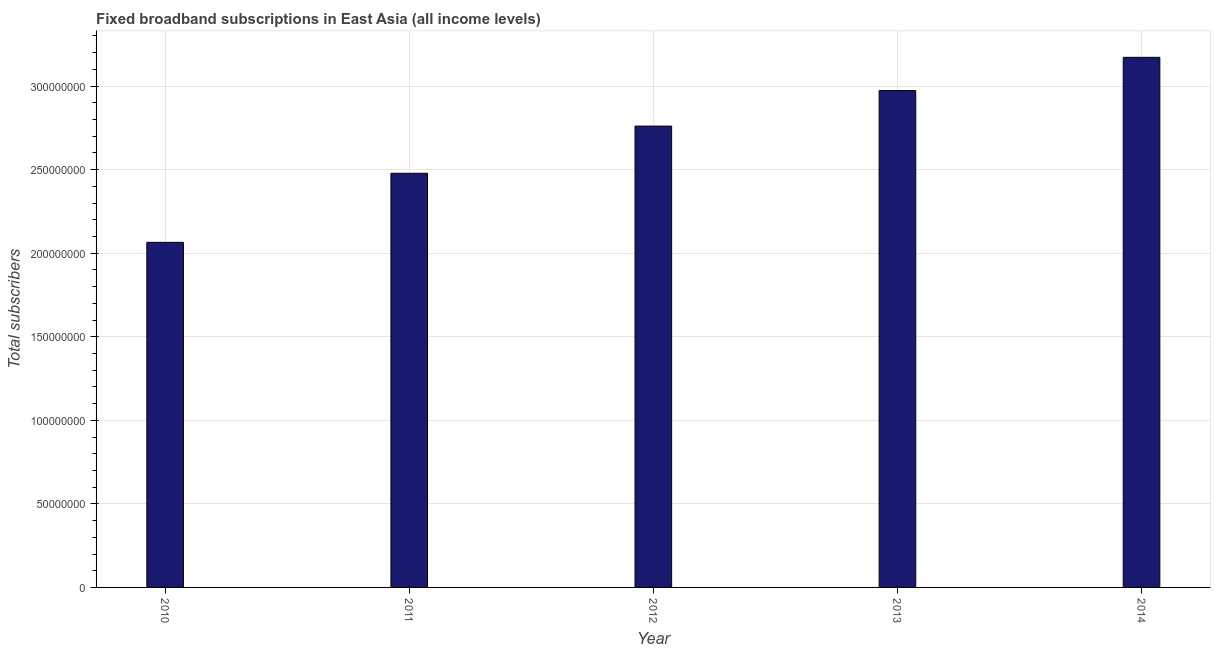What is the title of the graph?
Make the answer very short. Fixed broadband subscriptions in East Asia (all income levels). What is the label or title of the Y-axis?
Your response must be concise. Total subscribers. What is the total number of fixed broadband subscriptions in 2012?
Your response must be concise. 2.76e+08. Across all years, what is the maximum total number of fixed broadband subscriptions?
Make the answer very short. 3.17e+08. Across all years, what is the minimum total number of fixed broadband subscriptions?
Keep it short and to the point. 2.06e+08. In which year was the total number of fixed broadband subscriptions minimum?
Offer a very short reply. 2010. What is the sum of the total number of fixed broadband subscriptions?
Your answer should be compact. 1.34e+09. What is the difference between the total number of fixed broadband subscriptions in 2012 and 2013?
Your answer should be compact. -2.12e+07. What is the average total number of fixed broadband subscriptions per year?
Make the answer very short. 2.69e+08. What is the median total number of fixed broadband subscriptions?
Keep it short and to the point. 2.76e+08. In how many years, is the total number of fixed broadband subscriptions greater than 70000000 ?
Provide a succinct answer. 5. What is the ratio of the total number of fixed broadband subscriptions in 2011 to that in 2013?
Your answer should be compact. 0.83. Is the difference between the total number of fixed broadband subscriptions in 2010 and 2012 greater than the difference between any two years?
Your answer should be very brief. No. What is the difference between the highest and the second highest total number of fixed broadband subscriptions?
Offer a terse response. 1.99e+07. Is the sum of the total number of fixed broadband subscriptions in 2011 and 2012 greater than the maximum total number of fixed broadband subscriptions across all years?
Offer a very short reply. Yes. What is the difference between the highest and the lowest total number of fixed broadband subscriptions?
Offer a very short reply. 1.11e+08. In how many years, is the total number of fixed broadband subscriptions greater than the average total number of fixed broadband subscriptions taken over all years?
Your answer should be very brief. 3. Are all the bars in the graph horizontal?
Your answer should be very brief. No. What is the difference between two consecutive major ticks on the Y-axis?
Offer a very short reply. 5.00e+07. What is the Total subscribers in 2010?
Provide a succinct answer. 2.06e+08. What is the Total subscribers in 2011?
Provide a short and direct response. 2.48e+08. What is the Total subscribers in 2012?
Provide a succinct answer. 2.76e+08. What is the Total subscribers of 2013?
Make the answer very short. 2.97e+08. What is the Total subscribers in 2014?
Offer a very short reply. 3.17e+08. What is the difference between the Total subscribers in 2010 and 2011?
Ensure brevity in your answer.  -4.13e+07. What is the difference between the Total subscribers in 2010 and 2012?
Keep it short and to the point. -6.96e+07. What is the difference between the Total subscribers in 2010 and 2013?
Provide a succinct answer. -9.08e+07. What is the difference between the Total subscribers in 2010 and 2014?
Give a very brief answer. -1.11e+08. What is the difference between the Total subscribers in 2011 and 2012?
Your answer should be compact. -2.82e+07. What is the difference between the Total subscribers in 2011 and 2013?
Keep it short and to the point. -4.95e+07. What is the difference between the Total subscribers in 2011 and 2014?
Give a very brief answer. -6.94e+07. What is the difference between the Total subscribers in 2012 and 2013?
Offer a very short reply. -2.12e+07. What is the difference between the Total subscribers in 2012 and 2014?
Your response must be concise. -4.11e+07. What is the difference between the Total subscribers in 2013 and 2014?
Offer a very short reply. -1.99e+07. What is the ratio of the Total subscribers in 2010 to that in 2011?
Offer a terse response. 0.83. What is the ratio of the Total subscribers in 2010 to that in 2012?
Offer a terse response. 0.75. What is the ratio of the Total subscribers in 2010 to that in 2013?
Give a very brief answer. 0.69. What is the ratio of the Total subscribers in 2010 to that in 2014?
Offer a terse response. 0.65. What is the ratio of the Total subscribers in 2011 to that in 2012?
Give a very brief answer. 0.9. What is the ratio of the Total subscribers in 2011 to that in 2013?
Offer a very short reply. 0.83. What is the ratio of the Total subscribers in 2011 to that in 2014?
Keep it short and to the point. 0.78. What is the ratio of the Total subscribers in 2012 to that in 2013?
Give a very brief answer. 0.93. What is the ratio of the Total subscribers in 2012 to that in 2014?
Your answer should be compact. 0.87. What is the ratio of the Total subscribers in 2013 to that in 2014?
Your answer should be compact. 0.94. 